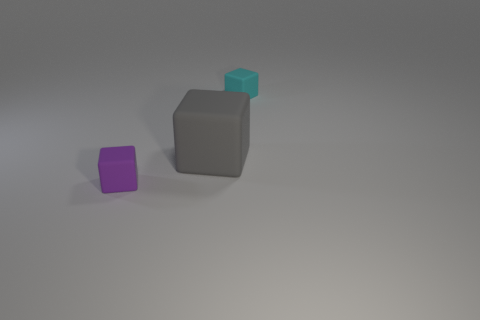Add 2 small yellow metallic cubes. How many objects exist? 5 Subtract 0 green spheres. How many objects are left? 3 Subtract all tiny cyan matte things. Subtract all purple shiny objects. How many objects are left? 2 Add 2 cubes. How many cubes are left? 5 Add 2 large gray things. How many large gray things exist? 3 